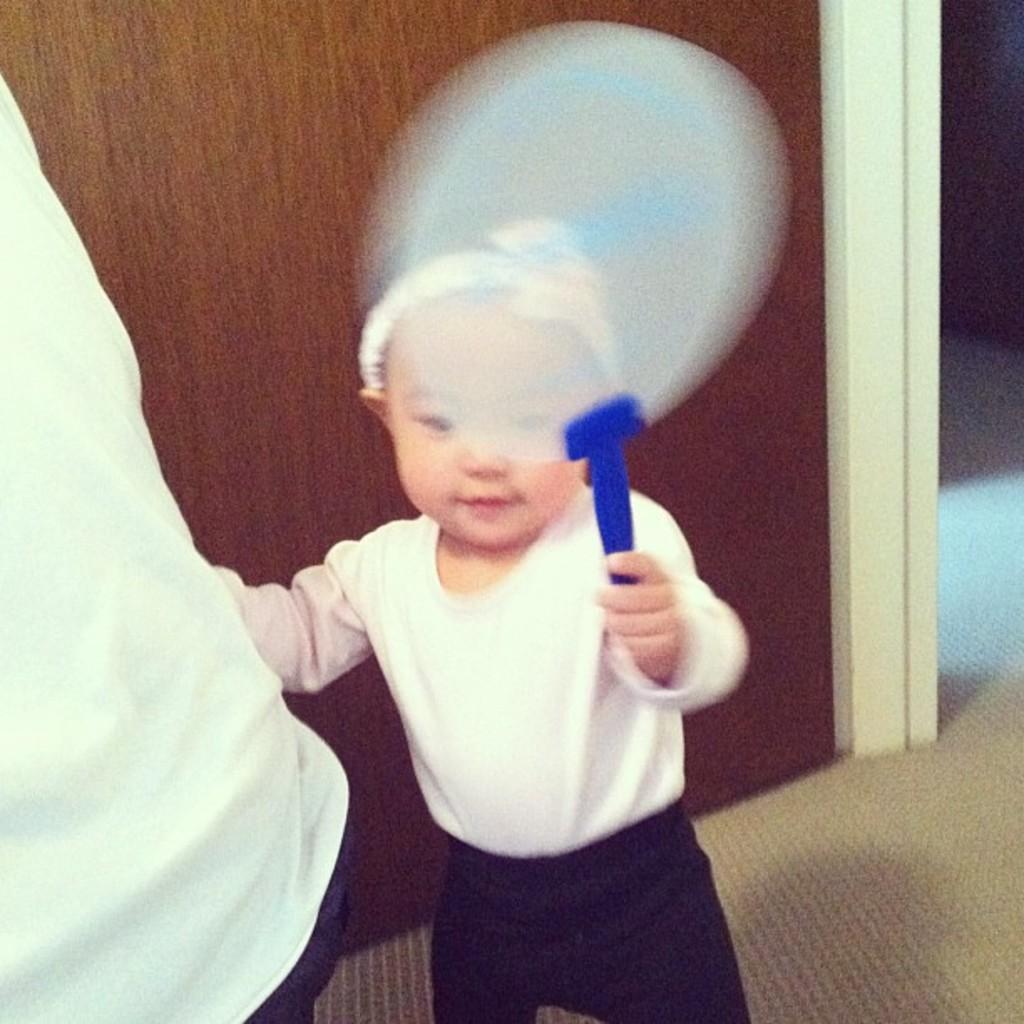How would you summarize this image in a sentence or two? Here I can see a baby is holding an object in the hand and standing. On the left side there is a person wearing white color dress. In the background there is a wooden board. At the bottom, I can see the floor. 